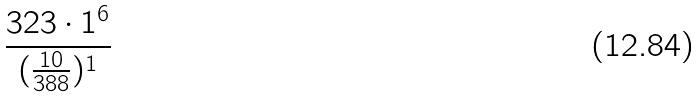Convert formula to latex. <formula><loc_0><loc_0><loc_500><loc_500>\frac { 3 2 3 \cdot 1 ^ { 6 } } { ( \frac { 1 0 } { 3 8 8 } ) ^ { 1 } }</formula> 